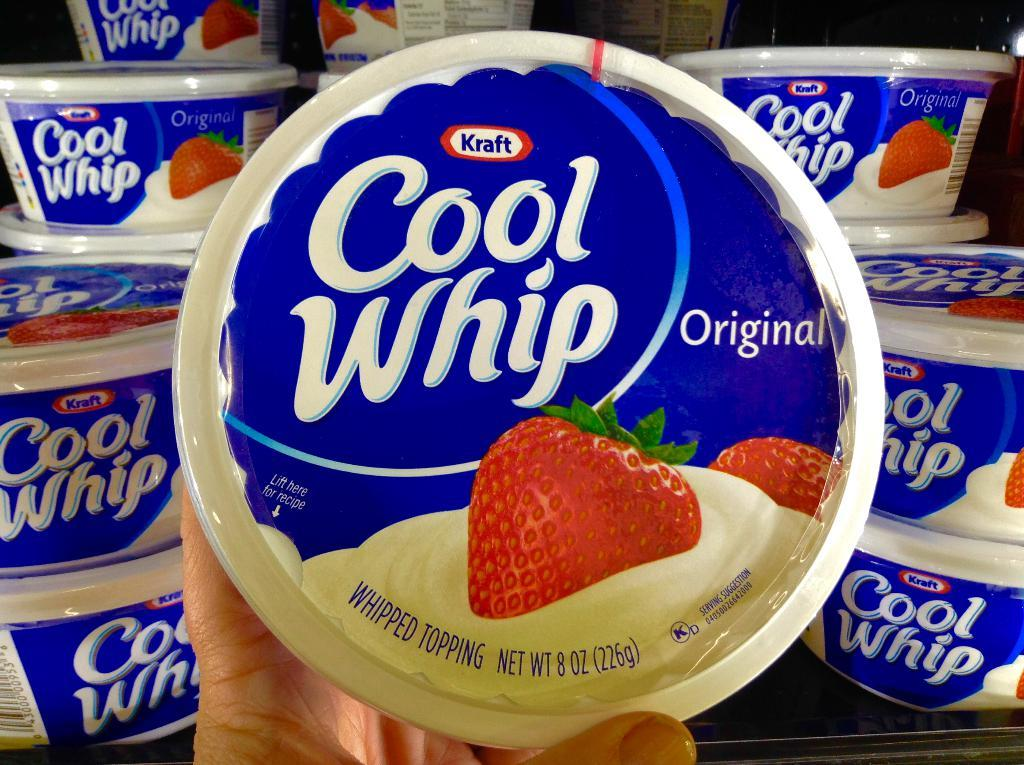What is the person in the image holding? The person is holding a cup. Can you describe the arrangement of cups in the background? There are cups arranged on a table in the background. What is the color of the background in the image? The background is dark in color. What type of town can be seen in the background of the image? There is no town visible in the background of the image; it is dark in color. How many icicles are hanging from the person's cup in the image? There are no icicles present in the image. Is there a fight taking place between the person and the cups in the image? There is no fight depicted in the image; the person is simply holding a cup. 